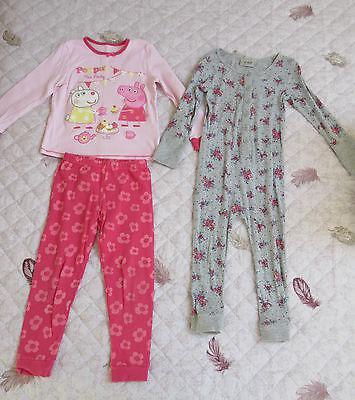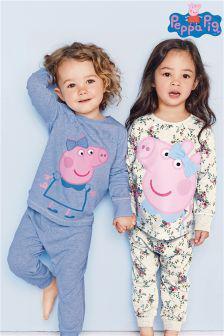The first image is the image on the left, the second image is the image on the right. For the images displayed, is the sentence "Some outfits feature a pink cartoon pig, and each image contains exactly two sleepwear outfits." factually correct? Answer yes or no. Yes. The first image is the image on the left, the second image is the image on the right. For the images displayed, is the sentence "Clothing is being modeled by children in each of the images." factually correct? Answer yes or no. No. 